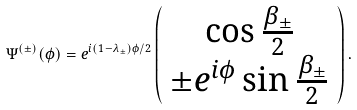<formula> <loc_0><loc_0><loc_500><loc_500>\Psi ^ { ( \pm ) } ( \phi ) = e ^ { i ( 1 - \lambda _ { \pm } ) \phi / 2 } \left ( \begin{array} { c } \cos { \frac { \beta _ { \pm } } { 2 } } \\ \pm e ^ { i \phi } \sin { \frac { \beta _ { \pm } } { 2 } } \end{array} \right ) .</formula> 